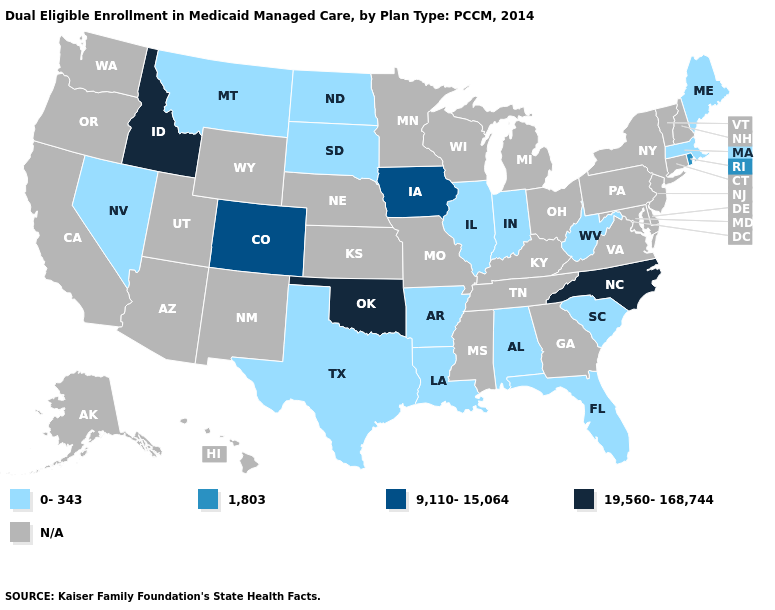Name the states that have a value in the range 9,110-15,064?
Answer briefly. Colorado, Iowa. Among the states that border Ohio , which have the highest value?
Answer briefly. Indiana, West Virginia. Name the states that have a value in the range 1,803?
Keep it brief. Rhode Island. Name the states that have a value in the range 0-343?
Answer briefly. Alabama, Arkansas, Florida, Illinois, Indiana, Louisiana, Maine, Massachusetts, Montana, Nevada, North Dakota, South Carolina, South Dakota, Texas, West Virginia. What is the value of Washington?
Short answer required. N/A. What is the highest value in the MidWest ?
Keep it brief. 9,110-15,064. Does Oklahoma have the highest value in the South?
Concise answer only. Yes. Name the states that have a value in the range 19,560-168,744?
Short answer required. Idaho, North Carolina, Oklahoma. Does the first symbol in the legend represent the smallest category?
Concise answer only. Yes. Which states have the lowest value in the West?
Give a very brief answer. Montana, Nevada. Which states hav the highest value in the West?
Keep it brief. Idaho. What is the value of Mississippi?
Write a very short answer. N/A. Name the states that have a value in the range 1,803?
Be succinct. Rhode Island. Does Alabama have the lowest value in the South?
Quick response, please. Yes. Does the first symbol in the legend represent the smallest category?
Concise answer only. Yes. 